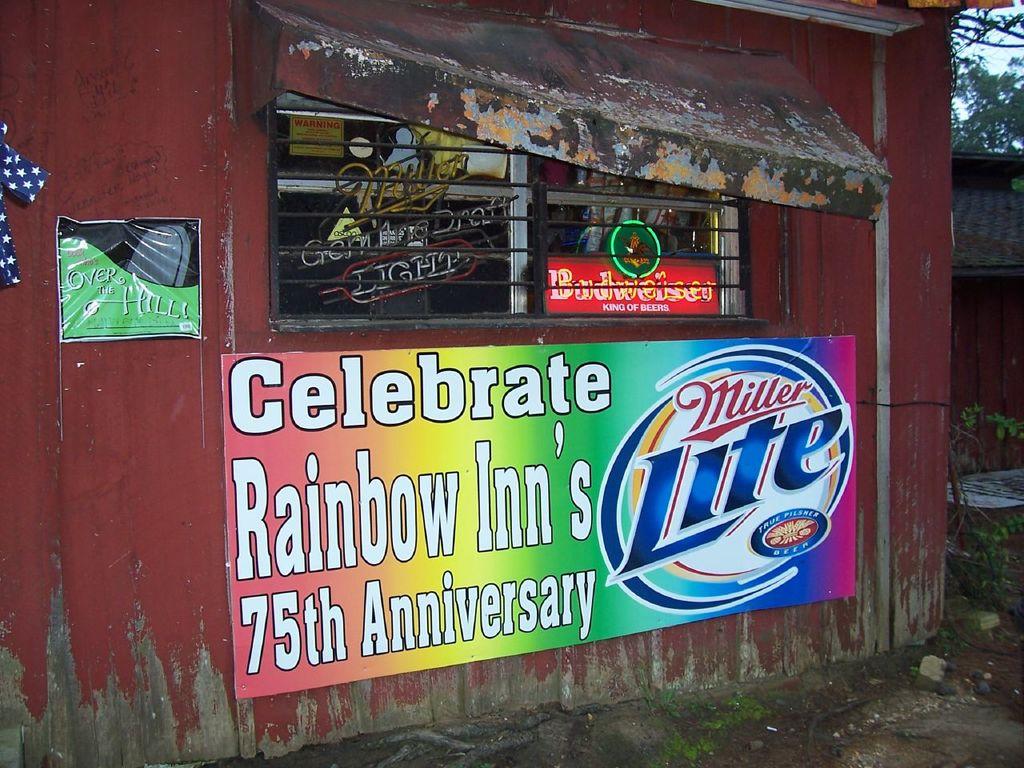What number anniversary are they celebrating?
Your answer should be compact. 75th. 